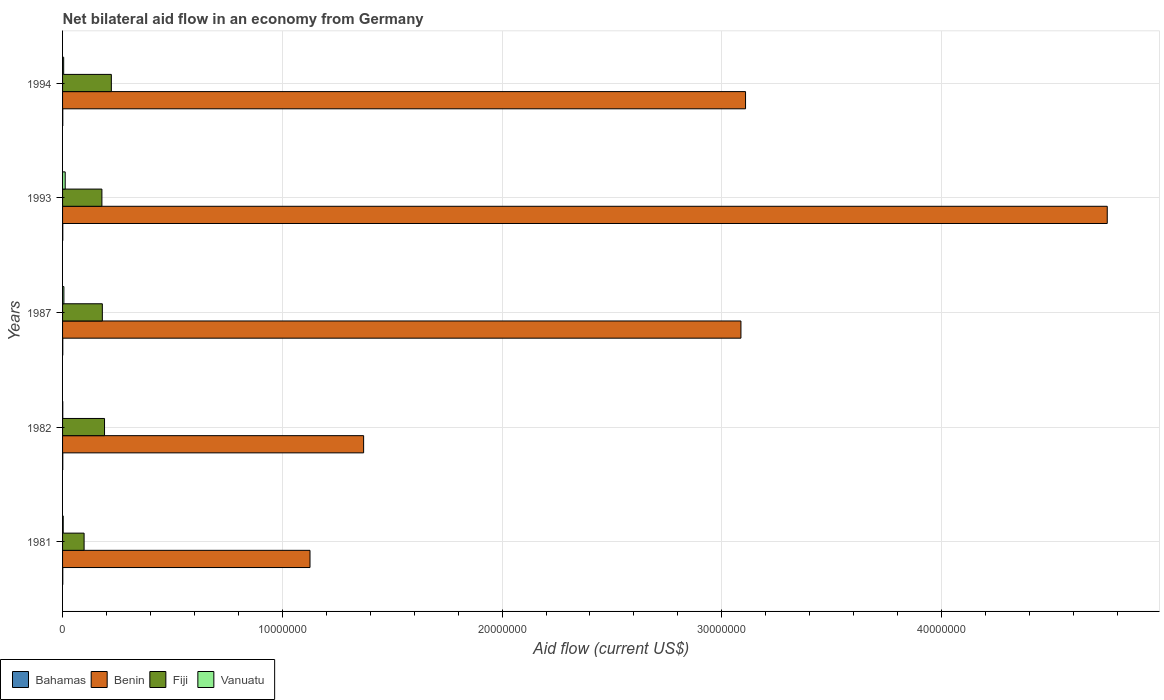Are the number of bars per tick equal to the number of legend labels?
Your answer should be very brief. Yes. What is the label of the 1st group of bars from the top?
Give a very brief answer. 1994. In how many cases, is the number of bars for a given year not equal to the number of legend labels?
Your answer should be compact. 0. Across all years, what is the maximum net bilateral aid flow in Benin?
Your response must be concise. 4.75e+07. Across all years, what is the minimum net bilateral aid flow in Benin?
Your response must be concise. 1.13e+07. In which year was the net bilateral aid flow in Benin minimum?
Give a very brief answer. 1981. What is the total net bilateral aid flow in Bahamas in the graph?
Your answer should be very brief. 5.00e+04. What is the difference between the net bilateral aid flow in Benin in 1993 and the net bilateral aid flow in Vanuatu in 1982?
Offer a terse response. 4.75e+07. What is the average net bilateral aid flow in Vanuatu per year?
Your answer should be compact. 5.40e+04. In the year 1981, what is the difference between the net bilateral aid flow in Fiji and net bilateral aid flow in Bahamas?
Your answer should be compact. 9.70e+05. In how many years, is the net bilateral aid flow in Benin greater than 22000000 US$?
Keep it short and to the point. 3. What is the ratio of the net bilateral aid flow in Fiji in 1982 to that in 1994?
Make the answer very short. 0.86. What is the difference between the highest and the second highest net bilateral aid flow in Fiji?
Offer a very short reply. 3.10e+05. What is the difference between the highest and the lowest net bilateral aid flow in Bahamas?
Your answer should be compact. 0. In how many years, is the net bilateral aid flow in Bahamas greater than the average net bilateral aid flow in Bahamas taken over all years?
Give a very brief answer. 0. What does the 2nd bar from the top in 1982 represents?
Your response must be concise. Fiji. What does the 4th bar from the bottom in 1982 represents?
Offer a very short reply. Vanuatu. Are all the bars in the graph horizontal?
Your answer should be compact. Yes. How many years are there in the graph?
Your answer should be compact. 5. Where does the legend appear in the graph?
Keep it short and to the point. Bottom left. How many legend labels are there?
Provide a succinct answer. 4. What is the title of the graph?
Your answer should be very brief. Net bilateral aid flow in an economy from Germany. Does "Bolivia" appear as one of the legend labels in the graph?
Your answer should be compact. No. What is the label or title of the X-axis?
Provide a succinct answer. Aid flow (current US$). What is the label or title of the Y-axis?
Your response must be concise. Years. What is the Aid flow (current US$) in Benin in 1981?
Ensure brevity in your answer.  1.13e+07. What is the Aid flow (current US$) of Fiji in 1981?
Give a very brief answer. 9.80e+05. What is the Aid flow (current US$) in Vanuatu in 1981?
Your response must be concise. 3.00e+04. What is the Aid flow (current US$) of Benin in 1982?
Provide a short and direct response. 1.37e+07. What is the Aid flow (current US$) of Fiji in 1982?
Your answer should be compact. 1.91e+06. What is the Aid flow (current US$) of Bahamas in 1987?
Ensure brevity in your answer.  10000. What is the Aid flow (current US$) of Benin in 1987?
Offer a terse response. 3.09e+07. What is the Aid flow (current US$) in Fiji in 1987?
Your answer should be very brief. 1.81e+06. What is the Aid flow (current US$) of Vanuatu in 1987?
Keep it short and to the point. 6.00e+04. What is the Aid flow (current US$) of Benin in 1993?
Give a very brief answer. 4.75e+07. What is the Aid flow (current US$) in Fiji in 1993?
Ensure brevity in your answer.  1.79e+06. What is the Aid flow (current US$) of Vanuatu in 1993?
Provide a short and direct response. 1.20e+05. What is the Aid flow (current US$) in Benin in 1994?
Keep it short and to the point. 3.11e+07. What is the Aid flow (current US$) in Fiji in 1994?
Offer a terse response. 2.22e+06. Across all years, what is the maximum Aid flow (current US$) in Benin?
Provide a short and direct response. 4.75e+07. Across all years, what is the maximum Aid flow (current US$) of Fiji?
Give a very brief answer. 2.22e+06. Across all years, what is the maximum Aid flow (current US$) of Vanuatu?
Your answer should be very brief. 1.20e+05. Across all years, what is the minimum Aid flow (current US$) in Benin?
Your answer should be very brief. 1.13e+07. Across all years, what is the minimum Aid flow (current US$) of Fiji?
Give a very brief answer. 9.80e+05. What is the total Aid flow (current US$) of Benin in the graph?
Provide a succinct answer. 1.34e+08. What is the total Aid flow (current US$) in Fiji in the graph?
Give a very brief answer. 8.71e+06. What is the total Aid flow (current US$) of Vanuatu in the graph?
Ensure brevity in your answer.  2.70e+05. What is the difference between the Aid flow (current US$) of Bahamas in 1981 and that in 1982?
Your answer should be very brief. 0. What is the difference between the Aid flow (current US$) of Benin in 1981 and that in 1982?
Your response must be concise. -2.44e+06. What is the difference between the Aid flow (current US$) in Fiji in 1981 and that in 1982?
Your answer should be very brief. -9.30e+05. What is the difference between the Aid flow (current US$) in Benin in 1981 and that in 1987?
Your response must be concise. -1.96e+07. What is the difference between the Aid flow (current US$) of Fiji in 1981 and that in 1987?
Give a very brief answer. -8.30e+05. What is the difference between the Aid flow (current US$) of Bahamas in 1981 and that in 1993?
Provide a succinct answer. 0. What is the difference between the Aid flow (current US$) in Benin in 1981 and that in 1993?
Your response must be concise. -3.63e+07. What is the difference between the Aid flow (current US$) of Fiji in 1981 and that in 1993?
Ensure brevity in your answer.  -8.10e+05. What is the difference between the Aid flow (current US$) of Vanuatu in 1981 and that in 1993?
Provide a succinct answer. -9.00e+04. What is the difference between the Aid flow (current US$) in Bahamas in 1981 and that in 1994?
Give a very brief answer. 0. What is the difference between the Aid flow (current US$) of Benin in 1981 and that in 1994?
Provide a short and direct response. -1.98e+07. What is the difference between the Aid flow (current US$) of Fiji in 1981 and that in 1994?
Provide a short and direct response. -1.24e+06. What is the difference between the Aid flow (current US$) of Bahamas in 1982 and that in 1987?
Give a very brief answer. 0. What is the difference between the Aid flow (current US$) of Benin in 1982 and that in 1987?
Your answer should be compact. -1.72e+07. What is the difference between the Aid flow (current US$) of Vanuatu in 1982 and that in 1987?
Provide a short and direct response. -5.00e+04. What is the difference between the Aid flow (current US$) of Bahamas in 1982 and that in 1993?
Your answer should be very brief. 0. What is the difference between the Aid flow (current US$) in Benin in 1982 and that in 1993?
Offer a very short reply. -3.38e+07. What is the difference between the Aid flow (current US$) of Vanuatu in 1982 and that in 1993?
Your answer should be very brief. -1.10e+05. What is the difference between the Aid flow (current US$) in Bahamas in 1982 and that in 1994?
Your answer should be compact. 0. What is the difference between the Aid flow (current US$) in Benin in 1982 and that in 1994?
Keep it short and to the point. -1.74e+07. What is the difference between the Aid flow (current US$) of Fiji in 1982 and that in 1994?
Offer a very short reply. -3.10e+05. What is the difference between the Aid flow (current US$) of Benin in 1987 and that in 1993?
Keep it short and to the point. -1.67e+07. What is the difference between the Aid flow (current US$) in Benin in 1987 and that in 1994?
Give a very brief answer. -2.10e+05. What is the difference between the Aid flow (current US$) in Fiji in 1987 and that in 1994?
Provide a short and direct response. -4.10e+05. What is the difference between the Aid flow (current US$) of Vanuatu in 1987 and that in 1994?
Offer a very short reply. 10000. What is the difference between the Aid flow (current US$) of Bahamas in 1993 and that in 1994?
Ensure brevity in your answer.  0. What is the difference between the Aid flow (current US$) of Benin in 1993 and that in 1994?
Provide a succinct answer. 1.65e+07. What is the difference between the Aid flow (current US$) in Fiji in 1993 and that in 1994?
Offer a very short reply. -4.30e+05. What is the difference between the Aid flow (current US$) of Bahamas in 1981 and the Aid flow (current US$) of Benin in 1982?
Your response must be concise. -1.37e+07. What is the difference between the Aid flow (current US$) of Bahamas in 1981 and the Aid flow (current US$) of Fiji in 1982?
Make the answer very short. -1.90e+06. What is the difference between the Aid flow (current US$) in Benin in 1981 and the Aid flow (current US$) in Fiji in 1982?
Provide a short and direct response. 9.35e+06. What is the difference between the Aid flow (current US$) of Benin in 1981 and the Aid flow (current US$) of Vanuatu in 1982?
Your answer should be compact. 1.12e+07. What is the difference between the Aid flow (current US$) of Fiji in 1981 and the Aid flow (current US$) of Vanuatu in 1982?
Provide a succinct answer. 9.70e+05. What is the difference between the Aid flow (current US$) in Bahamas in 1981 and the Aid flow (current US$) in Benin in 1987?
Provide a succinct answer. -3.09e+07. What is the difference between the Aid flow (current US$) in Bahamas in 1981 and the Aid flow (current US$) in Fiji in 1987?
Offer a very short reply. -1.80e+06. What is the difference between the Aid flow (current US$) in Bahamas in 1981 and the Aid flow (current US$) in Vanuatu in 1987?
Your answer should be compact. -5.00e+04. What is the difference between the Aid flow (current US$) in Benin in 1981 and the Aid flow (current US$) in Fiji in 1987?
Ensure brevity in your answer.  9.45e+06. What is the difference between the Aid flow (current US$) in Benin in 1981 and the Aid flow (current US$) in Vanuatu in 1987?
Give a very brief answer. 1.12e+07. What is the difference between the Aid flow (current US$) in Fiji in 1981 and the Aid flow (current US$) in Vanuatu in 1987?
Give a very brief answer. 9.20e+05. What is the difference between the Aid flow (current US$) of Bahamas in 1981 and the Aid flow (current US$) of Benin in 1993?
Provide a short and direct response. -4.75e+07. What is the difference between the Aid flow (current US$) of Bahamas in 1981 and the Aid flow (current US$) of Fiji in 1993?
Your answer should be compact. -1.78e+06. What is the difference between the Aid flow (current US$) in Bahamas in 1981 and the Aid flow (current US$) in Vanuatu in 1993?
Ensure brevity in your answer.  -1.10e+05. What is the difference between the Aid flow (current US$) in Benin in 1981 and the Aid flow (current US$) in Fiji in 1993?
Your answer should be very brief. 9.47e+06. What is the difference between the Aid flow (current US$) in Benin in 1981 and the Aid flow (current US$) in Vanuatu in 1993?
Make the answer very short. 1.11e+07. What is the difference between the Aid flow (current US$) of Fiji in 1981 and the Aid flow (current US$) of Vanuatu in 1993?
Make the answer very short. 8.60e+05. What is the difference between the Aid flow (current US$) of Bahamas in 1981 and the Aid flow (current US$) of Benin in 1994?
Ensure brevity in your answer.  -3.11e+07. What is the difference between the Aid flow (current US$) of Bahamas in 1981 and the Aid flow (current US$) of Fiji in 1994?
Your answer should be compact. -2.21e+06. What is the difference between the Aid flow (current US$) in Benin in 1981 and the Aid flow (current US$) in Fiji in 1994?
Offer a very short reply. 9.04e+06. What is the difference between the Aid flow (current US$) in Benin in 1981 and the Aid flow (current US$) in Vanuatu in 1994?
Keep it short and to the point. 1.12e+07. What is the difference between the Aid flow (current US$) in Fiji in 1981 and the Aid flow (current US$) in Vanuatu in 1994?
Make the answer very short. 9.30e+05. What is the difference between the Aid flow (current US$) in Bahamas in 1982 and the Aid flow (current US$) in Benin in 1987?
Your answer should be very brief. -3.09e+07. What is the difference between the Aid flow (current US$) in Bahamas in 1982 and the Aid flow (current US$) in Fiji in 1987?
Provide a succinct answer. -1.80e+06. What is the difference between the Aid flow (current US$) of Bahamas in 1982 and the Aid flow (current US$) of Vanuatu in 1987?
Provide a succinct answer. -5.00e+04. What is the difference between the Aid flow (current US$) of Benin in 1982 and the Aid flow (current US$) of Fiji in 1987?
Keep it short and to the point. 1.19e+07. What is the difference between the Aid flow (current US$) in Benin in 1982 and the Aid flow (current US$) in Vanuatu in 1987?
Ensure brevity in your answer.  1.36e+07. What is the difference between the Aid flow (current US$) of Fiji in 1982 and the Aid flow (current US$) of Vanuatu in 1987?
Provide a succinct answer. 1.85e+06. What is the difference between the Aid flow (current US$) of Bahamas in 1982 and the Aid flow (current US$) of Benin in 1993?
Give a very brief answer. -4.75e+07. What is the difference between the Aid flow (current US$) of Bahamas in 1982 and the Aid flow (current US$) of Fiji in 1993?
Your answer should be compact. -1.78e+06. What is the difference between the Aid flow (current US$) in Benin in 1982 and the Aid flow (current US$) in Fiji in 1993?
Your response must be concise. 1.19e+07. What is the difference between the Aid flow (current US$) in Benin in 1982 and the Aid flow (current US$) in Vanuatu in 1993?
Your answer should be very brief. 1.36e+07. What is the difference between the Aid flow (current US$) in Fiji in 1982 and the Aid flow (current US$) in Vanuatu in 1993?
Keep it short and to the point. 1.79e+06. What is the difference between the Aid flow (current US$) of Bahamas in 1982 and the Aid flow (current US$) of Benin in 1994?
Offer a very short reply. -3.11e+07. What is the difference between the Aid flow (current US$) in Bahamas in 1982 and the Aid flow (current US$) in Fiji in 1994?
Offer a terse response. -2.21e+06. What is the difference between the Aid flow (current US$) in Bahamas in 1982 and the Aid flow (current US$) in Vanuatu in 1994?
Your answer should be very brief. -4.00e+04. What is the difference between the Aid flow (current US$) in Benin in 1982 and the Aid flow (current US$) in Fiji in 1994?
Provide a short and direct response. 1.15e+07. What is the difference between the Aid flow (current US$) in Benin in 1982 and the Aid flow (current US$) in Vanuatu in 1994?
Offer a very short reply. 1.36e+07. What is the difference between the Aid flow (current US$) of Fiji in 1982 and the Aid flow (current US$) of Vanuatu in 1994?
Provide a succinct answer. 1.86e+06. What is the difference between the Aid flow (current US$) in Bahamas in 1987 and the Aid flow (current US$) in Benin in 1993?
Offer a very short reply. -4.75e+07. What is the difference between the Aid flow (current US$) of Bahamas in 1987 and the Aid flow (current US$) of Fiji in 1993?
Ensure brevity in your answer.  -1.78e+06. What is the difference between the Aid flow (current US$) in Bahamas in 1987 and the Aid flow (current US$) in Vanuatu in 1993?
Ensure brevity in your answer.  -1.10e+05. What is the difference between the Aid flow (current US$) of Benin in 1987 and the Aid flow (current US$) of Fiji in 1993?
Provide a succinct answer. 2.91e+07. What is the difference between the Aid flow (current US$) in Benin in 1987 and the Aid flow (current US$) in Vanuatu in 1993?
Make the answer very short. 3.08e+07. What is the difference between the Aid flow (current US$) of Fiji in 1987 and the Aid flow (current US$) of Vanuatu in 1993?
Provide a succinct answer. 1.69e+06. What is the difference between the Aid flow (current US$) in Bahamas in 1987 and the Aid flow (current US$) in Benin in 1994?
Offer a very short reply. -3.11e+07. What is the difference between the Aid flow (current US$) in Bahamas in 1987 and the Aid flow (current US$) in Fiji in 1994?
Keep it short and to the point. -2.21e+06. What is the difference between the Aid flow (current US$) of Bahamas in 1987 and the Aid flow (current US$) of Vanuatu in 1994?
Your response must be concise. -4.00e+04. What is the difference between the Aid flow (current US$) in Benin in 1987 and the Aid flow (current US$) in Fiji in 1994?
Offer a very short reply. 2.86e+07. What is the difference between the Aid flow (current US$) of Benin in 1987 and the Aid flow (current US$) of Vanuatu in 1994?
Provide a short and direct response. 3.08e+07. What is the difference between the Aid flow (current US$) of Fiji in 1987 and the Aid flow (current US$) of Vanuatu in 1994?
Offer a terse response. 1.76e+06. What is the difference between the Aid flow (current US$) of Bahamas in 1993 and the Aid flow (current US$) of Benin in 1994?
Offer a terse response. -3.11e+07. What is the difference between the Aid flow (current US$) in Bahamas in 1993 and the Aid flow (current US$) in Fiji in 1994?
Your response must be concise. -2.21e+06. What is the difference between the Aid flow (current US$) of Bahamas in 1993 and the Aid flow (current US$) of Vanuatu in 1994?
Provide a succinct answer. -4.00e+04. What is the difference between the Aid flow (current US$) of Benin in 1993 and the Aid flow (current US$) of Fiji in 1994?
Your response must be concise. 4.53e+07. What is the difference between the Aid flow (current US$) in Benin in 1993 and the Aid flow (current US$) in Vanuatu in 1994?
Make the answer very short. 4.75e+07. What is the difference between the Aid flow (current US$) in Fiji in 1993 and the Aid flow (current US$) in Vanuatu in 1994?
Provide a short and direct response. 1.74e+06. What is the average Aid flow (current US$) of Benin per year?
Give a very brief answer. 2.69e+07. What is the average Aid flow (current US$) of Fiji per year?
Provide a succinct answer. 1.74e+06. What is the average Aid flow (current US$) of Vanuatu per year?
Keep it short and to the point. 5.40e+04. In the year 1981, what is the difference between the Aid flow (current US$) in Bahamas and Aid flow (current US$) in Benin?
Offer a terse response. -1.12e+07. In the year 1981, what is the difference between the Aid flow (current US$) in Bahamas and Aid flow (current US$) in Fiji?
Make the answer very short. -9.70e+05. In the year 1981, what is the difference between the Aid flow (current US$) in Benin and Aid flow (current US$) in Fiji?
Ensure brevity in your answer.  1.03e+07. In the year 1981, what is the difference between the Aid flow (current US$) of Benin and Aid flow (current US$) of Vanuatu?
Keep it short and to the point. 1.12e+07. In the year 1981, what is the difference between the Aid flow (current US$) in Fiji and Aid flow (current US$) in Vanuatu?
Offer a very short reply. 9.50e+05. In the year 1982, what is the difference between the Aid flow (current US$) of Bahamas and Aid flow (current US$) of Benin?
Provide a succinct answer. -1.37e+07. In the year 1982, what is the difference between the Aid flow (current US$) in Bahamas and Aid flow (current US$) in Fiji?
Keep it short and to the point. -1.90e+06. In the year 1982, what is the difference between the Aid flow (current US$) in Bahamas and Aid flow (current US$) in Vanuatu?
Offer a very short reply. 0. In the year 1982, what is the difference between the Aid flow (current US$) of Benin and Aid flow (current US$) of Fiji?
Keep it short and to the point. 1.18e+07. In the year 1982, what is the difference between the Aid flow (current US$) in Benin and Aid flow (current US$) in Vanuatu?
Provide a short and direct response. 1.37e+07. In the year 1982, what is the difference between the Aid flow (current US$) in Fiji and Aid flow (current US$) in Vanuatu?
Offer a very short reply. 1.90e+06. In the year 1987, what is the difference between the Aid flow (current US$) in Bahamas and Aid flow (current US$) in Benin?
Keep it short and to the point. -3.09e+07. In the year 1987, what is the difference between the Aid flow (current US$) in Bahamas and Aid flow (current US$) in Fiji?
Your answer should be compact. -1.80e+06. In the year 1987, what is the difference between the Aid flow (current US$) in Bahamas and Aid flow (current US$) in Vanuatu?
Your answer should be very brief. -5.00e+04. In the year 1987, what is the difference between the Aid flow (current US$) in Benin and Aid flow (current US$) in Fiji?
Offer a very short reply. 2.91e+07. In the year 1987, what is the difference between the Aid flow (current US$) in Benin and Aid flow (current US$) in Vanuatu?
Provide a short and direct response. 3.08e+07. In the year 1987, what is the difference between the Aid flow (current US$) of Fiji and Aid flow (current US$) of Vanuatu?
Provide a succinct answer. 1.75e+06. In the year 1993, what is the difference between the Aid flow (current US$) in Bahamas and Aid flow (current US$) in Benin?
Provide a succinct answer. -4.75e+07. In the year 1993, what is the difference between the Aid flow (current US$) in Bahamas and Aid flow (current US$) in Fiji?
Offer a very short reply. -1.78e+06. In the year 1993, what is the difference between the Aid flow (current US$) in Benin and Aid flow (current US$) in Fiji?
Offer a very short reply. 4.58e+07. In the year 1993, what is the difference between the Aid flow (current US$) of Benin and Aid flow (current US$) of Vanuatu?
Keep it short and to the point. 4.74e+07. In the year 1993, what is the difference between the Aid flow (current US$) in Fiji and Aid flow (current US$) in Vanuatu?
Your response must be concise. 1.67e+06. In the year 1994, what is the difference between the Aid flow (current US$) in Bahamas and Aid flow (current US$) in Benin?
Ensure brevity in your answer.  -3.11e+07. In the year 1994, what is the difference between the Aid flow (current US$) in Bahamas and Aid flow (current US$) in Fiji?
Keep it short and to the point. -2.21e+06. In the year 1994, what is the difference between the Aid flow (current US$) in Bahamas and Aid flow (current US$) in Vanuatu?
Offer a terse response. -4.00e+04. In the year 1994, what is the difference between the Aid flow (current US$) of Benin and Aid flow (current US$) of Fiji?
Provide a short and direct response. 2.89e+07. In the year 1994, what is the difference between the Aid flow (current US$) in Benin and Aid flow (current US$) in Vanuatu?
Your response must be concise. 3.10e+07. In the year 1994, what is the difference between the Aid flow (current US$) of Fiji and Aid flow (current US$) of Vanuatu?
Make the answer very short. 2.17e+06. What is the ratio of the Aid flow (current US$) of Benin in 1981 to that in 1982?
Make the answer very short. 0.82. What is the ratio of the Aid flow (current US$) in Fiji in 1981 to that in 1982?
Offer a very short reply. 0.51. What is the ratio of the Aid flow (current US$) in Benin in 1981 to that in 1987?
Give a very brief answer. 0.36. What is the ratio of the Aid flow (current US$) of Fiji in 1981 to that in 1987?
Your answer should be compact. 0.54. What is the ratio of the Aid flow (current US$) of Vanuatu in 1981 to that in 1987?
Provide a short and direct response. 0.5. What is the ratio of the Aid flow (current US$) in Benin in 1981 to that in 1993?
Offer a terse response. 0.24. What is the ratio of the Aid flow (current US$) in Fiji in 1981 to that in 1993?
Your answer should be compact. 0.55. What is the ratio of the Aid flow (current US$) of Benin in 1981 to that in 1994?
Ensure brevity in your answer.  0.36. What is the ratio of the Aid flow (current US$) of Fiji in 1981 to that in 1994?
Provide a short and direct response. 0.44. What is the ratio of the Aid flow (current US$) of Vanuatu in 1981 to that in 1994?
Offer a terse response. 0.6. What is the ratio of the Aid flow (current US$) in Benin in 1982 to that in 1987?
Ensure brevity in your answer.  0.44. What is the ratio of the Aid flow (current US$) of Fiji in 1982 to that in 1987?
Provide a succinct answer. 1.06. What is the ratio of the Aid flow (current US$) in Vanuatu in 1982 to that in 1987?
Provide a short and direct response. 0.17. What is the ratio of the Aid flow (current US$) in Benin in 1982 to that in 1993?
Provide a succinct answer. 0.29. What is the ratio of the Aid flow (current US$) of Fiji in 1982 to that in 1993?
Your answer should be very brief. 1.07. What is the ratio of the Aid flow (current US$) in Vanuatu in 1982 to that in 1993?
Offer a very short reply. 0.08. What is the ratio of the Aid flow (current US$) in Bahamas in 1982 to that in 1994?
Offer a terse response. 1. What is the ratio of the Aid flow (current US$) in Benin in 1982 to that in 1994?
Give a very brief answer. 0.44. What is the ratio of the Aid flow (current US$) in Fiji in 1982 to that in 1994?
Keep it short and to the point. 0.86. What is the ratio of the Aid flow (current US$) in Bahamas in 1987 to that in 1993?
Your answer should be compact. 1. What is the ratio of the Aid flow (current US$) of Benin in 1987 to that in 1993?
Offer a terse response. 0.65. What is the ratio of the Aid flow (current US$) in Fiji in 1987 to that in 1993?
Provide a succinct answer. 1.01. What is the ratio of the Aid flow (current US$) of Vanuatu in 1987 to that in 1993?
Offer a terse response. 0.5. What is the ratio of the Aid flow (current US$) of Bahamas in 1987 to that in 1994?
Your answer should be compact. 1. What is the ratio of the Aid flow (current US$) in Benin in 1987 to that in 1994?
Offer a very short reply. 0.99. What is the ratio of the Aid flow (current US$) in Fiji in 1987 to that in 1994?
Offer a terse response. 0.82. What is the ratio of the Aid flow (current US$) in Bahamas in 1993 to that in 1994?
Offer a very short reply. 1. What is the ratio of the Aid flow (current US$) of Benin in 1993 to that in 1994?
Ensure brevity in your answer.  1.53. What is the ratio of the Aid flow (current US$) in Fiji in 1993 to that in 1994?
Provide a succinct answer. 0.81. What is the difference between the highest and the second highest Aid flow (current US$) of Benin?
Your response must be concise. 1.65e+07. What is the difference between the highest and the second highest Aid flow (current US$) in Fiji?
Provide a short and direct response. 3.10e+05. What is the difference between the highest and the second highest Aid flow (current US$) of Vanuatu?
Make the answer very short. 6.00e+04. What is the difference between the highest and the lowest Aid flow (current US$) in Benin?
Make the answer very short. 3.63e+07. What is the difference between the highest and the lowest Aid flow (current US$) in Fiji?
Provide a succinct answer. 1.24e+06. 